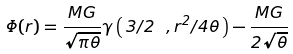Convert formula to latex. <formula><loc_0><loc_0><loc_500><loc_500>\Phi ( r ) = \frac { M G } { \sqrt { \pi \theta } } \gamma \left ( \, 3 / 2 \ , r ^ { 2 } / 4 \theta \, \right ) - \frac { M G } { 2 \sqrt { \theta } }</formula> 